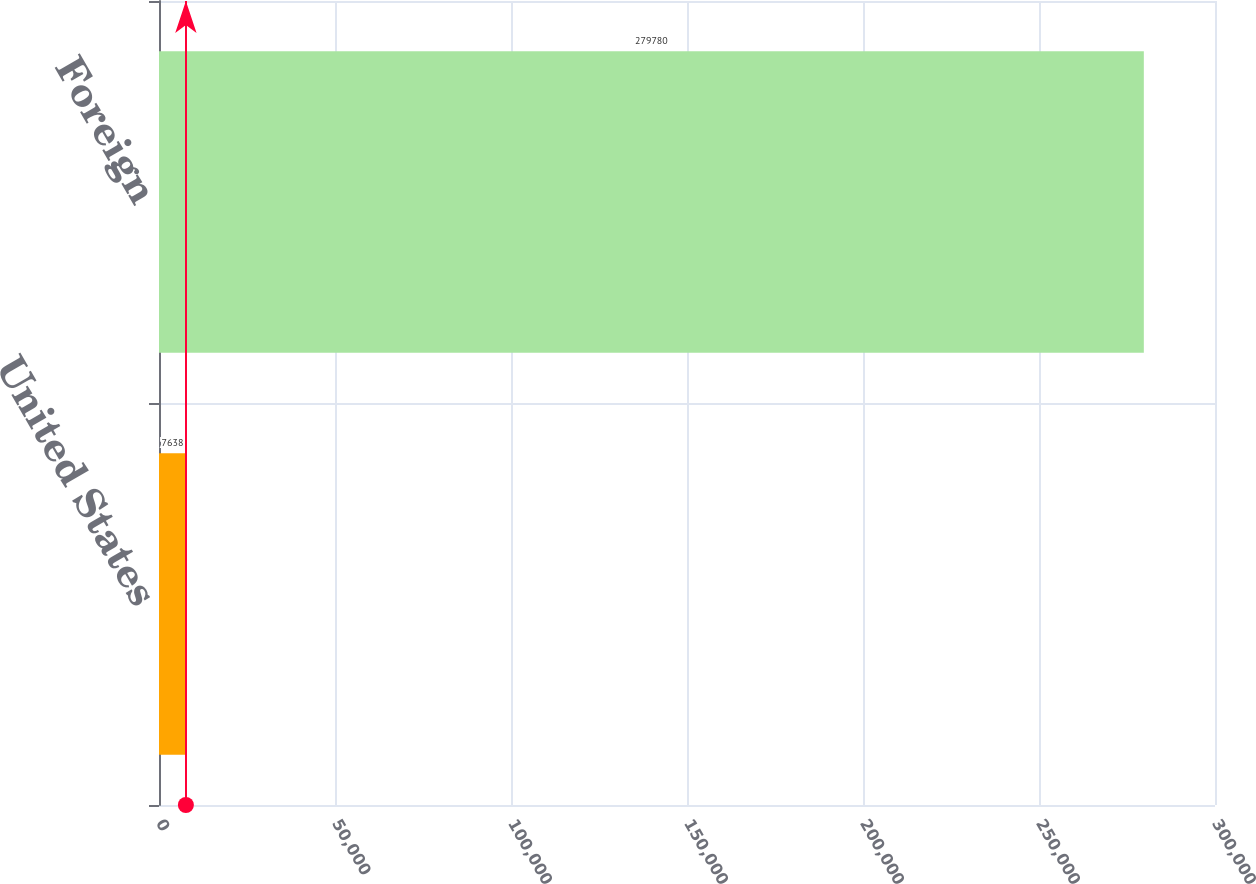Convert chart. <chart><loc_0><loc_0><loc_500><loc_500><bar_chart><fcel>United States<fcel>Foreign<nl><fcel>7638<fcel>279780<nl></chart> 